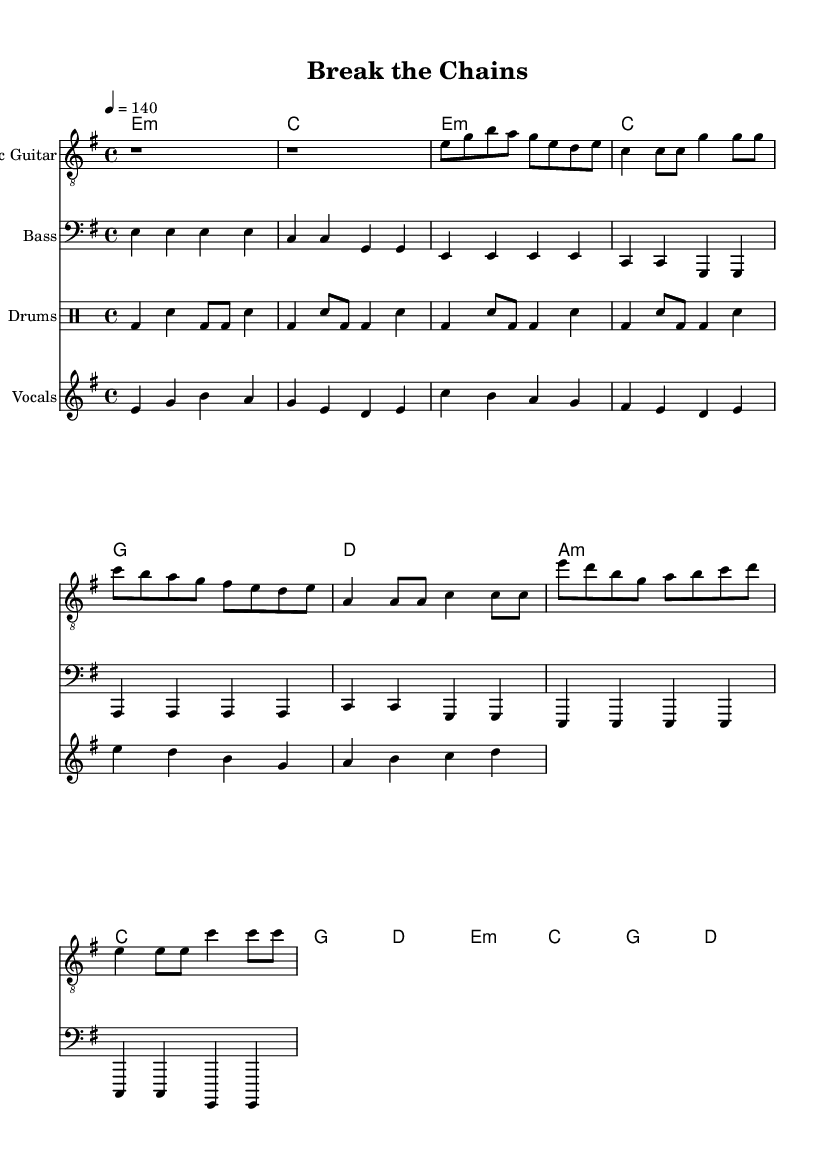What is the key signature of this music? The key signature is indicated by the sharp or flat symbols placed after the treble or bass clef at the beginning of the staff. In this sheet music, there are no sharps or flats shown, indicating that the key signature is E minor, which has one sharp.
Answer: E minor What is the time signature of this piece? The time signature is shown at the beginning of the staff, indicating how many beats are in each measure and what note gets the beat. Here, the time signature is 4/4, meaning four beats per measure and the quarter note gets one beat.
Answer: 4/4 What is the tempo marking for this piece? The tempo marking is indicated by a number followed by an equal sign and a number, located at the beginning of the score. In this case, it shows 4 = 140, which indicates the speed of the piece in beats per minute.
Answer: 140 How many measures are there in the verse? To determine the number of measures in the verse, you can count the measures in the section labeled as the verse. In this music, the verse contains a total of four measures.
Answer: 4 What type of guitar is featured in this score? The instrument type is typically indicated at the top of the respective staff. Here, the score specifies "Electric Guitar" for the guitar part, indicating it is an electric guitar arrangement.
Answer: Electric Guitar Which section contains the most distinct changes in dynamics? The chorus section often features increased dynamics and intensity compared to verse or pre-chorus sections. Reviewing the vocal and guitar parts, the chorus section introduces a more powerful and energetic melody, indicating a change in dynamics.
Answer: Chorus What is the primary theme conveyed by the lyrics in this anthem? By analyzing the titles and stanzas of the lyrics corresponding to the score, we can ascertain that the lyrics suggest themes of empowerment and breaking free from mental health stigma. This thematic approach aligns with common attributes found in hard rock anthems.
Answer: Empowerment 